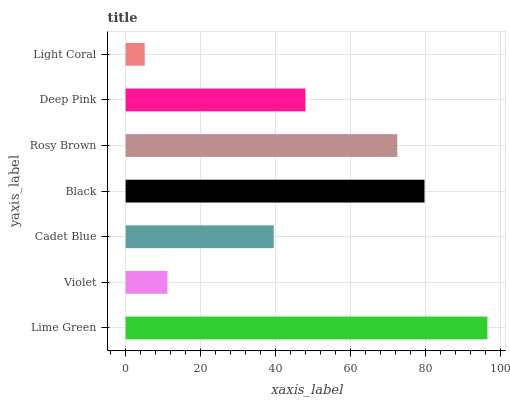Is Light Coral the minimum?
Answer yes or no. Yes. Is Lime Green the maximum?
Answer yes or no. Yes. Is Violet the minimum?
Answer yes or no. No. Is Violet the maximum?
Answer yes or no. No. Is Lime Green greater than Violet?
Answer yes or no. Yes. Is Violet less than Lime Green?
Answer yes or no. Yes. Is Violet greater than Lime Green?
Answer yes or no. No. Is Lime Green less than Violet?
Answer yes or no. No. Is Deep Pink the high median?
Answer yes or no. Yes. Is Deep Pink the low median?
Answer yes or no. Yes. Is Black the high median?
Answer yes or no. No. Is Light Coral the low median?
Answer yes or no. No. 